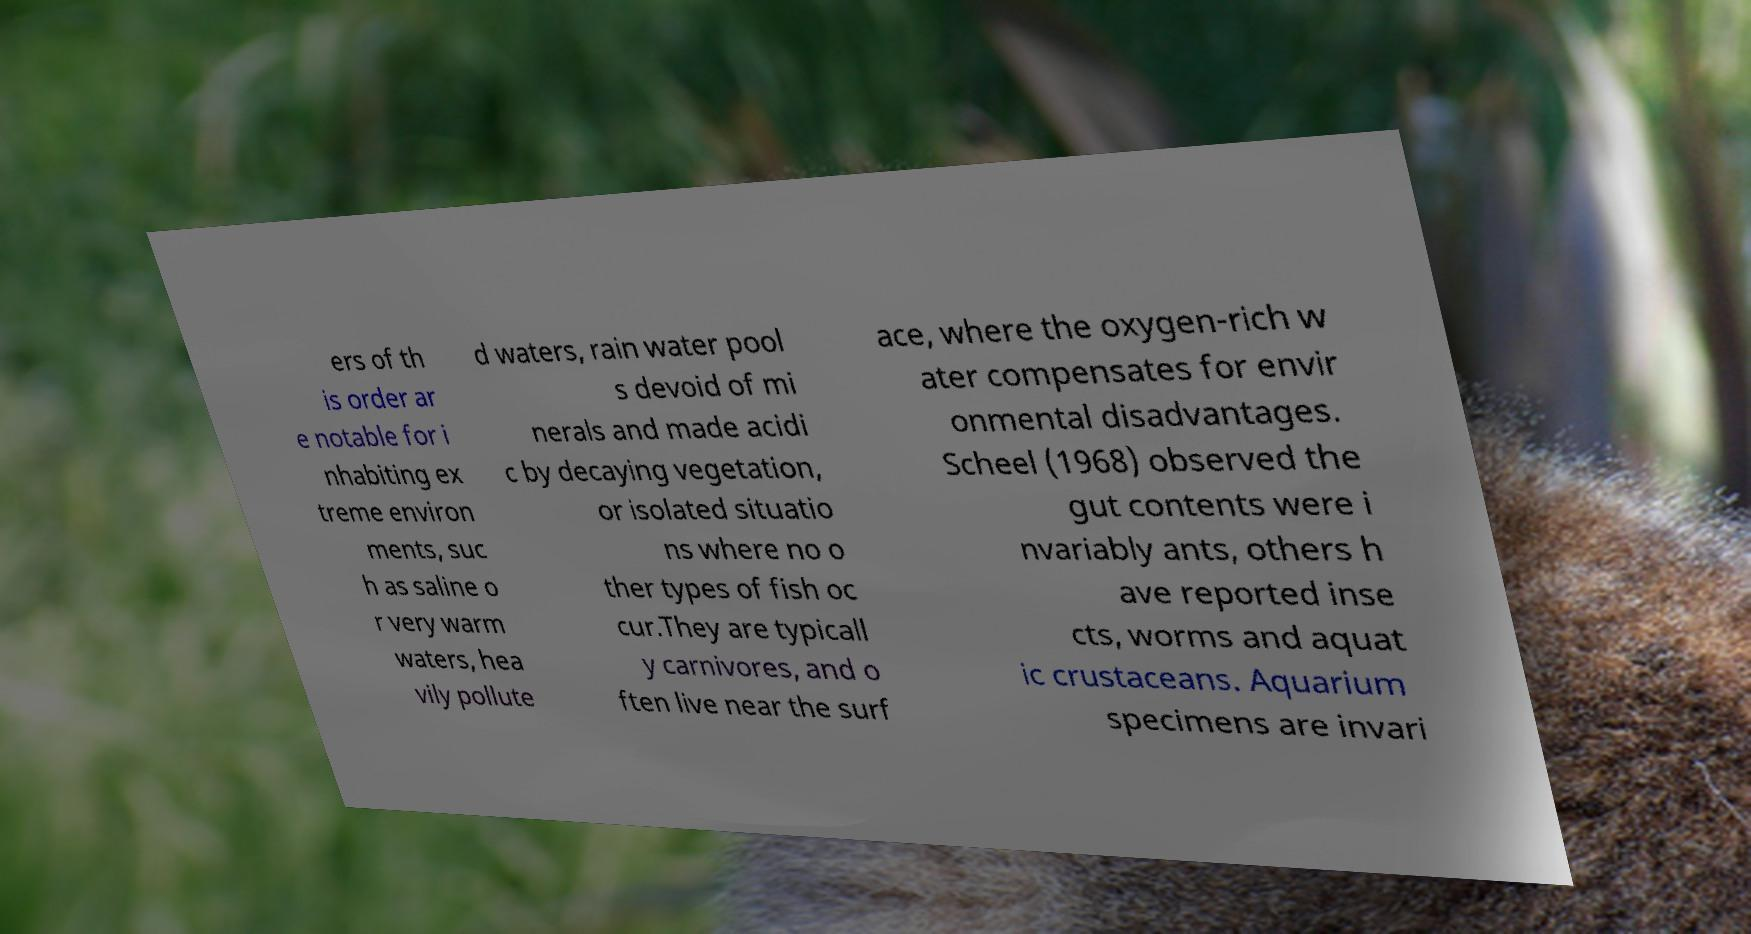I need the written content from this picture converted into text. Can you do that? ers of th is order ar e notable for i nhabiting ex treme environ ments, suc h as saline o r very warm waters, hea vily pollute d waters, rain water pool s devoid of mi nerals and made acidi c by decaying vegetation, or isolated situatio ns where no o ther types of fish oc cur.They are typicall y carnivores, and o ften live near the surf ace, where the oxygen-rich w ater compensates for envir onmental disadvantages. Scheel (1968) observed the gut contents were i nvariably ants, others h ave reported inse cts, worms and aquat ic crustaceans. Aquarium specimens are invari 